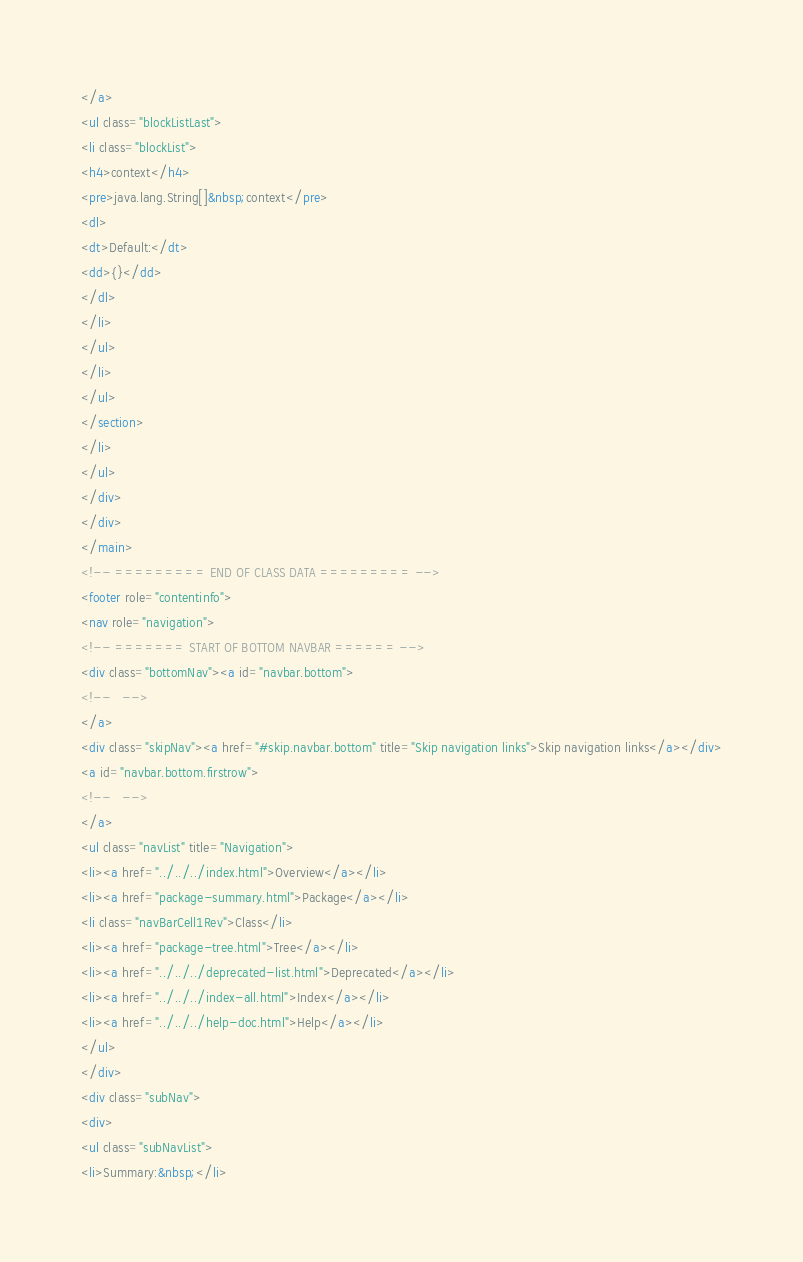Convert code to text. <code><loc_0><loc_0><loc_500><loc_500><_HTML_></a>
<ul class="blockListLast">
<li class="blockList">
<h4>context</h4>
<pre>java.lang.String[]&nbsp;context</pre>
<dl>
<dt>Default:</dt>
<dd>{}</dd>
</dl>
</li>
</ul>
</li>
</ul>
</section>
</li>
</ul>
</div>
</div>
</main>
<!-- ========= END OF CLASS DATA ========= -->
<footer role="contentinfo">
<nav role="navigation">
<!-- ======= START OF BOTTOM NAVBAR ====== -->
<div class="bottomNav"><a id="navbar.bottom">
<!--   -->
</a>
<div class="skipNav"><a href="#skip.navbar.bottom" title="Skip navigation links">Skip navigation links</a></div>
<a id="navbar.bottom.firstrow">
<!--   -->
</a>
<ul class="navList" title="Navigation">
<li><a href="../../../index.html">Overview</a></li>
<li><a href="package-summary.html">Package</a></li>
<li class="navBarCell1Rev">Class</li>
<li><a href="package-tree.html">Tree</a></li>
<li><a href="../../../deprecated-list.html">Deprecated</a></li>
<li><a href="../../../index-all.html">Index</a></li>
<li><a href="../../../help-doc.html">Help</a></li>
</ul>
</div>
<div class="subNav">
<div>
<ul class="subNavList">
<li>Summary:&nbsp;</li></code> 